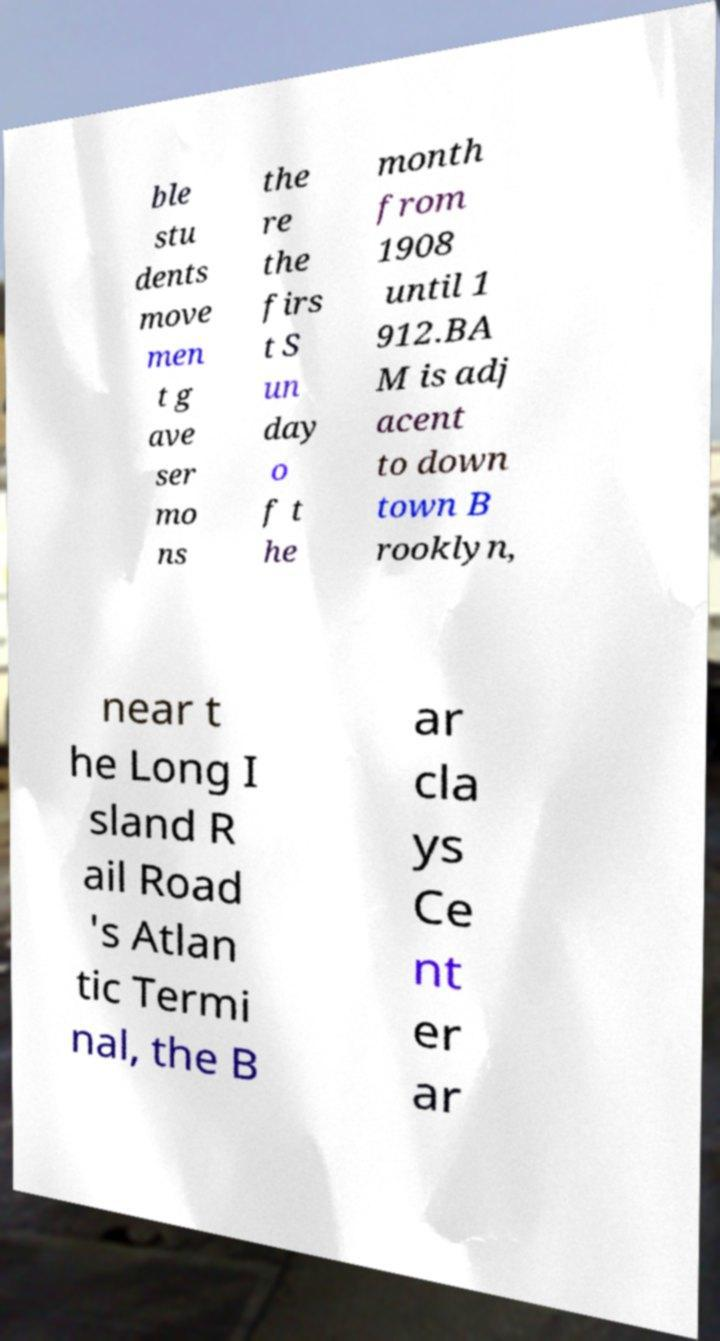What messages or text are displayed in this image? I need them in a readable, typed format. ble stu dents move men t g ave ser mo ns the re the firs t S un day o f t he month from 1908 until 1 912.BA M is adj acent to down town B rooklyn, near t he Long I sland R ail Road 's Atlan tic Termi nal, the B ar cla ys Ce nt er ar 